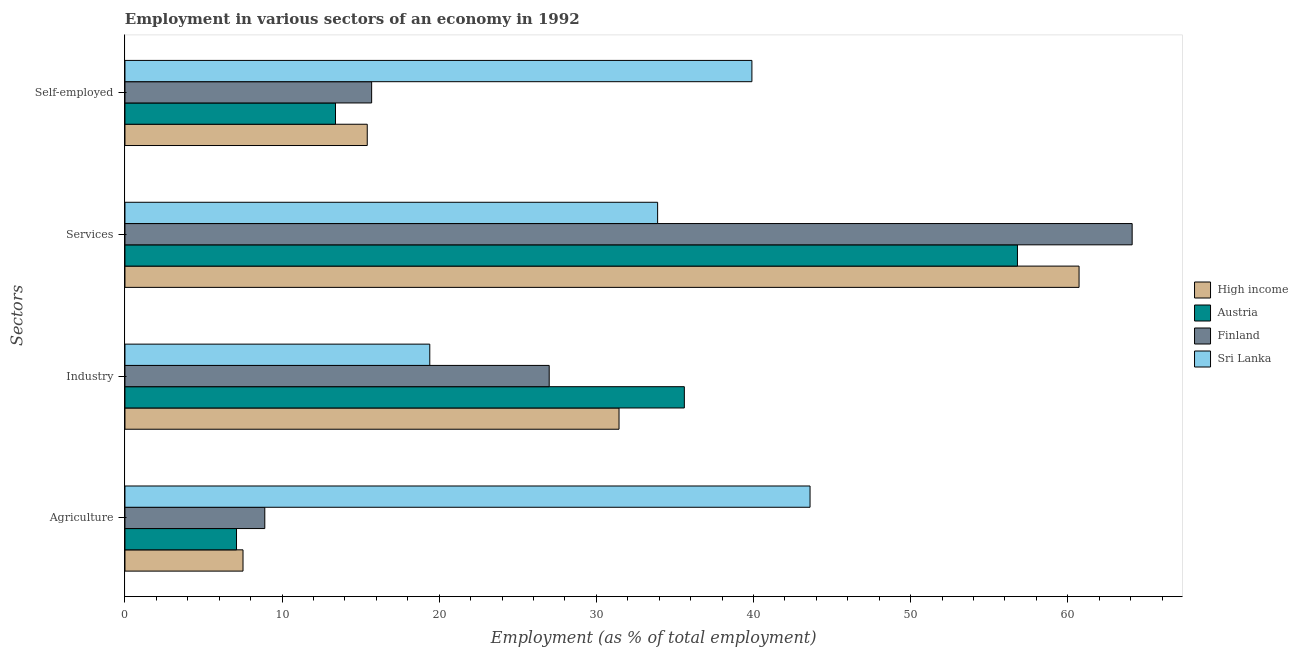How many groups of bars are there?
Provide a succinct answer. 4. Are the number of bars per tick equal to the number of legend labels?
Your response must be concise. Yes. How many bars are there on the 1st tick from the top?
Provide a short and direct response. 4. What is the label of the 1st group of bars from the top?
Keep it short and to the point. Self-employed. What is the percentage of workers in agriculture in Austria?
Provide a short and direct response. 7.1. Across all countries, what is the maximum percentage of self employed workers?
Offer a terse response. 39.9. Across all countries, what is the minimum percentage of self employed workers?
Your answer should be very brief. 13.4. In which country was the percentage of workers in industry maximum?
Ensure brevity in your answer.  Austria. In which country was the percentage of workers in agriculture minimum?
Your response must be concise. Austria. What is the total percentage of self employed workers in the graph?
Provide a short and direct response. 84.42. What is the difference between the percentage of self employed workers in High income and that in Finland?
Keep it short and to the point. -0.28. What is the difference between the percentage of workers in agriculture in High income and the percentage of workers in industry in Finland?
Offer a terse response. -19.49. What is the average percentage of self employed workers per country?
Make the answer very short. 21.11. What is the difference between the percentage of workers in services and percentage of self employed workers in Finland?
Give a very brief answer. 48.4. In how many countries, is the percentage of workers in industry greater than 52 %?
Keep it short and to the point. 0. What is the ratio of the percentage of workers in industry in Austria to that in Sri Lanka?
Keep it short and to the point. 1.84. What is the difference between the highest and the second highest percentage of workers in industry?
Your answer should be compact. 4.16. What is the difference between the highest and the lowest percentage of workers in agriculture?
Keep it short and to the point. 36.5. In how many countries, is the percentage of self employed workers greater than the average percentage of self employed workers taken over all countries?
Offer a very short reply. 1. Is it the case that in every country, the sum of the percentage of workers in services and percentage of workers in agriculture is greater than the sum of percentage of self employed workers and percentage of workers in industry?
Keep it short and to the point. Yes. How many bars are there?
Provide a short and direct response. 16. How many countries are there in the graph?
Give a very brief answer. 4. Does the graph contain any zero values?
Ensure brevity in your answer.  No. How many legend labels are there?
Make the answer very short. 4. What is the title of the graph?
Provide a short and direct response. Employment in various sectors of an economy in 1992. Does "Iran" appear as one of the legend labels in the graph?
Your answer should be compact. No. What is the label or title of the X-axis?
Provide a short and direct response. Employment (as % of total employment). What is the label or title of the Y-axis?
Provide a succinct answer. Sectors. What is the Employment (as % of total employment) in High income in Agriculture?
Give a very brief answer. 7.51. What is the Employment (as % of total employment) of Austria in Agriculture?
Your response must be concise. 7.1. What is the Employment (as % of total employment) of Finland in Agriculture?
Your answer should be compact. 8.9. What is the Employment (as % of total employment) in Sri Lanka in Agriculture?
Offer a very short reply. 43.6. What is the Employment (as % of total employment) of High income in Industry?
Keep it short and to the point. 31.44. What is the Employment (as % of total employment) of Austria in Industry?
Provide a succinct answer. 35.6. What is the Employment (as % of total employment) of Finland in Industry?
Your answer should be compact. 27. What is the Employment (as % of total employment) of Sri Lanka in Industry?
Ensure brevity in your answer.  19.4. What is the Employment (as % of total employment) in High income in Services?
Your answer should be very brief. 60.72. What is the Employment (as % of total employment) of Austria in Services?
Offer a terse response. 56.8. What is the Employment (as % of total employment) in Finland in Services?
Provide a succinct answer. 64.1. What is the Employment (as % of total employment) in Sri Lanka in Services?
Provide a succinct answer. 33.9. What is the Employment (as % of total employment) of High income in Self-employed?
Give a very brief answer. 15.42. What is the Employment (as % of total employment) in Austria in Self-employed?
Your response must be concise. 13.4. What is the Employment (as % of total employment) in Finland in Self-employed?
Your response must be concise. 15.7. What is the Employment (as % of total employment) of Sri Lanka in Self-employed?
Your answer should be compact. 39.9. Across all Sectors, what is the maximum Employment (as % of total employment) in High income?
Provide a short and direct response. 60.72. Across all Sectors, what is the maximum Employment (as % of total employment) in Austria?
Make the answer very short. 56.8. Across all Sectors, what is the maximum Employment (as % of total employment) in Finland?
Give a very brief answer. 64.1. Across all Sectors, what is the maximum Employment (as % of total employment) of Sri Lanka?
Keep it short and to the point. 43.6. Across all Sectors, what is the minimum Employment (as % of total employment) in High income?
Provide a succinct answer. 7.51. Across all Sectors, what is the minimum Employment (as % of total employment) of Austria?
Offer a terse response. 7.1. Across all Sectors, what is the minimum Employment (as % of total employment) of Finland?
Your response must be concise. 8.9. Across all Sectors, what is the minimum Employment (as % of total employment) of Sri Lanka?
Your answer should be compact. 19.4. What is the total Employment (as % of total employment) in High income in the graph?
Keep it short and to the point. 115.1. What is the total Employment (as % of total employment) of Austria in the graph?
Make the answer very short. 112.9. What is the total Employment (as % of total employment) of Finland in the graph?
Your answer should be very brief. 115.7. What is the total Employment (as % of total employment) of Sri Lanka in the graph?
Provide a short and direct response. 136.8. What is the difference between the Employment (as % of total employment) of High income in Agriculture and that in Industry?
Keep it short and to the point. -23.93. What is the difference between the Employment (as % of total employment) of Austria in Agriculture and that in Industry?
Your answer should be compact. -28.5. What is the difference between the Employment (as % of total employment) of Finland in Agriculture and that in Industry?
Your answer should be compact. -18.1. What is the difference between the Employment (as % of total employment) of Sri Lanka in Agriculture and that in Industry?
Give a very brief answer. 24.2. What is the difference between the Employment (as % of total employment) of High income in Agriculture and that in Services?
Your response must be concise. -53.21. What is the difference between the Employment (as % of total employment) of Austria in Agriculture and that in Services?
Your answer should be compact. -49.7. What is the difference between the Employment (as % of total employment) of Finland in Agriculture and that in Services?
Offer a very short reply. -55.2. What is the difference between the Employment (as % of total employment) in Sri Lanka in Agriculture and that in Services?
Offer a very short reply. 9.7. What is the difference between the Employment (as % of total employment) in High income in Agriculture and that in Self-employed?
Your response must be concise. -7.91. What is the difference between the Employment (as % of total employment) of Austria in Agriculture and that in Self-employed?
Offer a terse response. -6.3. What is the difference between the Employment (as % of total employment) of Finland in Agriculture and that in Self-employed?
Offer a very short reply. -6.8. What is the difference between the Employment (as % of total employment) in High income in Industry and that in Services?
Give a very brief answer. -29.28. What is the difference between the Employment (as % of total employment) of Austria in Industry and that in Services?
Give a very brief answer. -21.2. What is the difference between the Employment (as % of total employment) in Finland in Industry and that in Services?
Your answer should be compact. -37.1. What is the difference between the Employment (as % of total employment) of Sri Lanka in Industry and that in Services?
Your answer should be compact. -14.5. What is the difference between the Employment (as % of total employment) in High income in Industry and that in Self-employed?
Provide a short and direct response. 16.02. What is the difference between the Employment (as % of total employment) of Sri Lanka in Industry and that in Self-employed?
Provide a succinct answer. -20.5. What is the difference between the Employment (as % of total employment) of High income in Services and that in Self-employed?
Offer a very short reply. 45.3. What is the difference between the Employment (as % of total employment) of Austria in Services and that in Self-employed?
Make the answer very short. 43.4. What is the difference between the Employment (as % of total employment) in Finland in Services and that in Self-employed?
Your answer should be very brief. 48.4. What is the difference between the Employment (as % of total employment) in High income in Agriculture and the Employment (as % of total employment) in Austria in Industry?
Your response must be concise. -28.09. What is the difference between the Employment (as % of total employment) of High income in Agriculture and the Employment (as % of total employment) of Finland in Industry?
Keep it short and to the point. -19.49. What is the difference between the Employment (as % of total employment) in High income in Agriculture and the Employment (as % of total employment) in Sri Lanka in Industry?
Your response must be concise. -11.89. What is the difference between the Employment (as % of total employment) of Austria in Agriculture and the Employment (as % of total employment) of Finland in Industry?
Provide a succinct answer. -19.9. What is the difference between the Employment (as % of total employment) in Austria in Agriculture and the Employment (as % of total employment) in Sri Lanka in Industry?
Your answer should be very brief. -12.3. What is the difference between the Employment (as % of total employment) of Finland in Agriculture and the Employment (as % of total employment) of Sri Lanka in Industry?
Make the answer very short. -10.5. What is the difference between the Employment (as % of total employment) of High income in Agriculture and the Employment (as % of total employment) of Austria in Services?
Offer a very short reply. -49.29. What is the difference between the Employment (as % of total employment) of High income in Agriculture and the Employment (as % of total employment) of Finland in Services?
Offer a very short reply. -56.59. What is the difference between the Employment (as % of total employment) in High income in Agriculture and the Employment (as % of total employment) in Sri Lanka in Services?
Your response must be concise. -26.39. What is the difference between the Employment (as % of total employment) of Austria in Agriculture and the Employment (as % of total employment) of Finland in Services?
Offer a very short reply. -57. What is the difference between the Employment (as % of total employment) of Austria in Agriculture and the Employment (as % of total employment) of Sri Lanka in Services?
Give a very brief answer. -26.8. What is the difference between the Employment (as % of total employment) in Finland in Agriculture and the Employment (as % of total employment) in Sri Lanka in Services?
Keep it short and to the point. -25. What is the difference between the Employment (as % of total employment) of High income in Agriculture and the Employment (as % of total employment) of Austria in Self-employed?
Your answer should be compact. -5.89. What is the difference between the Employment (as % of total employment) in High income in Agriculture and the Employment (as % of total employment) in Finland in Self-employed?
Your answer should be compact. -8.19. What is the difference between the Employment (as % of total employment) in High income in Agriculture and the Employment (as % of total employment) in Sri Lanka in Self-employed?
Provide a succinct answer. -32.39. What is the difference between the Employment (as % of total employment) in Austria in Agriculture and the Employment (as % of total employment) in Sri Lanka in Self-employed?
Your response must be concise. -32.8. What is the difference between the Employment (as % of total employment) in Finland in Agriculture and the Employment (as % of total employment) in Sri Lanka in Self-employed?
Your response must be concise. -31. What is the difference between the Employment (as % of total employment) of High income in Industry and the Employment (as % of total employment) of Austria in Services?
Your answer should be very brief. -25.36. What is the difference between the Employment (as % of total employment) of High income in Industry and the Employment (as % of total employment) of Finland in Services?
Give a very brief answer. -32.66. What is the difference between the Employment (as % of total employment) of High income in Industry and the Employment (as % of total employment) of Sri Lanka in Services?
Give a very brief answer. -2.46. What is the difference between the Employment (as % of total employment) in Austria in Industry and the Employment (as % of total employment) in Finland in Services?
Your answer should be compact. -28.5. What is the difference between the Employment (as % of total employment) in Finland in Industry and the Employment (as % of total employment) in Sri Lanka in Services?
Offer a very short reply. -6.9. What is the difference between the Employment (as % of total employment) of High income in Industry and the Employment (as % of total employment) of Austria in Self-employed?
Give a very brief answer. 18.04. What is the difference between the Employment (as % of total employment) in High income in Industry and the Employment (as % of total employment) in Finland in Self-employed?
Offer a very short reply. 15.74. What is the difference between the Employment (as % of total employment) of High income in Industry and the Employment (as % of total employment) of Sri Lanka in Self-employed?
Provide a succinct answer. -8.46. What is the difference between the Employment (as % of total employment) in Austria in Industry and the Employment (as % of total employment) in Sri Lanka in Self-employed?
Your answer should be very brief. -4.3. What is the difference between the Employment (as % of total employment) of High income in Services and the Employment (as % of total employment) of Austria in Self-employed?
Your answer should be compact. 47.32. What is the difference between the Employment (as % of total employment) of High income in Services and the Employment (as % of total employment) of Finland in Self-employed?
Offer a terse response. 45.02. What is the difference between the Employment (as % of total employment) in High income in Services and the Employment (as % of total employment) in Sri Lanka in Self-employed?
Provide a succinct answer. 20.82. What is the difference between the Employment (as % of total employment) in Austria in Services and the Employment (as % of total employment) in Finland in Self-employed?
Provide a succinct answer. 41.1. What is the difference between the Employment (as % of total employment) in Finland in Services and the Employment (as % of total employment) in Sri Lanka in Self-employed?
Provide a succinct answer. 24.2. What is the average Employment (as % of total employment) of High income per Sectors?
Your answer should be very brief. 28.77. What is the average Employment (as % of total employment) of Austria per Sectors?
Keep it short and to the point. 28.23. What is the average Employment (as % of total employment) of Finland per Sectors?
Make the answer very short. 28.93. What is the average Employment (as % of total employment) of Sri Lanka per Sectors?
Offer a very short reply. 34.2. What is the difference between the Employment (as % of total employment) of High income and Employment (as % of total employment) of Austria in Agriculture?
Provide a succinct answer. 0.41. What is the difference between the Employment (as % of total employment) of High income and Employment (as % of total employment) of Finland in Agriculture?
Keep it short and to the point. -1.39. What is the difference between the Employment (as % of total employment) of High income and Employment (as % of total employment) of Sri Lanka in Agriculture?
Ensure brevity in your answer.  -36.09. What is the difference between the Employment (as % of total employment) in Austria and Employment (as % of total employment) in Sri Lanka in Agriculture?
Give a very brief answer. -36.5. What is the difference between the Employment (as % of total employment) in Finland and Employment (as % of total employment) in Sri Lanka in Agriculture?
Offer a very short reply. -34.7. What is the difference between the Employment (as % of total employment) in High income and Employment (as % of total employment) in Austria in Industry?
Your answer should be very brief. -4.16. What is the difference between the Employment (as % of total employment) of High income and Employment (as % of total employment) of Finland in Industry?
Ensure brevity in your answer.  4.44. What is the difference between the Employment (as % of total employment) of High income and Employment (as % of total employment) of Sri Lanka in Industry?
Your answer should be very brief. 12.04. What is the difference between the Employment (as % of total employment) in High income and Employment (as % of total employment) in Austria in Services?
Give a very brief answer. 3.92. What is the difference between the Employment (as % of total employment) in High income and Employment (as % of total employment) in Finland in Services?
Keep it short and to the point. -3.38. What is the difference between the Employment (as % of total employment) in High income and Employment (as % of total employment) in Sri Lanka in Services?
Offer a very short reply. 26.82. What is the difference between the Employment (as % of total employment) in Austria and Employment (as % of total employment) in Sri Lanka in Services?
Give a very brief answer. 22.9. What is the difference between the Employment (as % of total employment) in Finland and Employment (as % of total employment) in Sri Lanka in Services?
Keep it short and to the point. 30.2. What is the difference between the Employment (as % of total employment) of High income and Employment (as % of total employment) of Austria in Self-employed?
Your answer should be compact. 2.02. What is the difference between the Employment (as % of total employment) of High income and Employment (as % of total employment) of Finland in Self-employed?
Provide a short and direct response. -0.28. What is the difference between the Employment (as % of total employment) in High income and Employment (as % of total employment) in Sri Lanka in Self-employed?
Make the answer very short. -24.48. What is the difference between the Employment (as % of total employment) of Austria and Employment (as % of total employment) of Sri Lanka in Self-employed?
Your response must be concise. -26.5. What is the difference between the Employment (as % of total employment) in Finland and Employment (as % of total employment) in Sri Lanka in Self-employed?
Offer a terse response. -24.2. What is the ratio of the Employment (as % of total employment) of High income in Agriculture to that in Industry?
Offer a terse response. 0.24. What is the ratio of the Employment (as % of total employment) of Austria in Agriculture to that in Industry?
Ensure brevity in your answer.  0.2. What is the ratio of the Employment (as % of total employment) of Finland in Agriculture to that in Industry?
Ensure brevity in your answer.  0.33. What is the ratio of the Employment (as % of total employment) of Sri Lanka in Agriculture to that in Industry?
Your response must be concise. 2.25. What is the ratio of the Employment (as % of total employment) in High income in Agriculture to that in Services?
Give a very brief answer. 0.12. What is the ratio of the Employment (as % of total employment) in Austria in Agriculture to that in Services?
Keep it short and to the point. 0.12. What is the ratio of the Employment (as % of total employment) of Finland in Agriculture to that in Services?
Provide a succinct answer. 0.14. What is the ratio of the Employment (as % of total employment) in Sri Lanka in Agriculture to that in Services?
Offer a very short reply. 1.29. What is the ratio of the Employment (as % of total employment) in High income in Agriculture to that in Self-employed?
Provide a succinct answer. 0.49. What is the ratio of the Employment (as % of total employment) of Austria in Agriculture to that in Self-employed?
Your response must be concise. 0.53. What is the ratio of the Employment (as % of total employment) of Finland in Agriculture to that in Self-employed?
Provide a short and direct response. 0.57. What is the ratio of the Employment (as % of total employment) of Sri Lanka in Agriculture to that in Self-employed?
Your response must be concise. 1.09. What is the ratio of the Employment (as % of total employment) in High income in Industry to that in Services?
Make the answer very short. 0.52. What is the ratio of the Employment (as % of total employment) of Austria in Industry to that in Services?
Provide a short and direct response. 0.63. What is the ratio of the Employment (as % of total employment) of Finland in Industry to that in Services?
Provide a succinct answer. 0.42. What is the ratio of the Employment (as % of total employment) of Sri Lanka in Industry to that in Services?
Provide a succinct answer. 0.57. What is the ratio of the Employment (as % of total employment) of High income in Industry to that in Self-employed?
Give a very brief answer. 2.04. What is the ratio of the Employment (as % of total employment) in Austria in Industry to that in Self-employed?
Give a very brief answer. 2.66. What is the ratio of the Employment (as % of total employment) of Finland in Industry to that in Self-employed?
Your response must be concise. 1.72. What is the ratio of the Employment (as % of total employment) of Sri Lanka in Industry to that in Self-employed?
Make the answer very short. 0.49. What is the ratio of the Employment (as % of total employment) in High income in Services to that in Self-employed?
Provide a succinct answer. 3.94. What is the ratio of the Employment (as % of total employment) of Austria in Services to that in Self-employed?
Keep it short and to the point. 4.24. What is the ratio of the Employment (as % of total employment) of Finland in Services to that in Self-employed?
Ensure brevity in your answer.  4.08. What is the ratio of the Employment (as % of total employment) in Sri Lanka in Services to that in Self-employed?
Offer a terse response. 0.85. What is the difference between the highest and the second highest Employment (as % of total employment) of High income?
Your answer should be compact. 29.28. What is the difference between the highest and the second highest Employment (as % of total employment) in Austria?
Your answer should be very brief. 21.2. What is the difference between the highest and the second highest Employment (as % of total employment) of Finland?
Offer a terse response. 37.1. What is the difference between the highest and the lowest Employment (as % of total employment) in High income?
Provide a short and direct response. 53.21. What is the difference between the highest and the lowest Employment (as % of total employment) of Austria?
Provide a short and direct response. 49.7. What is the difference between the highest and the lowest Employment (as % of total employment) in Finland?
Provide a succinct answer. 55.2. What is the difference between the highest and the lowest Employment (as % of total employment) in Sri Lanka?
Offer a terse response. 24.2. 